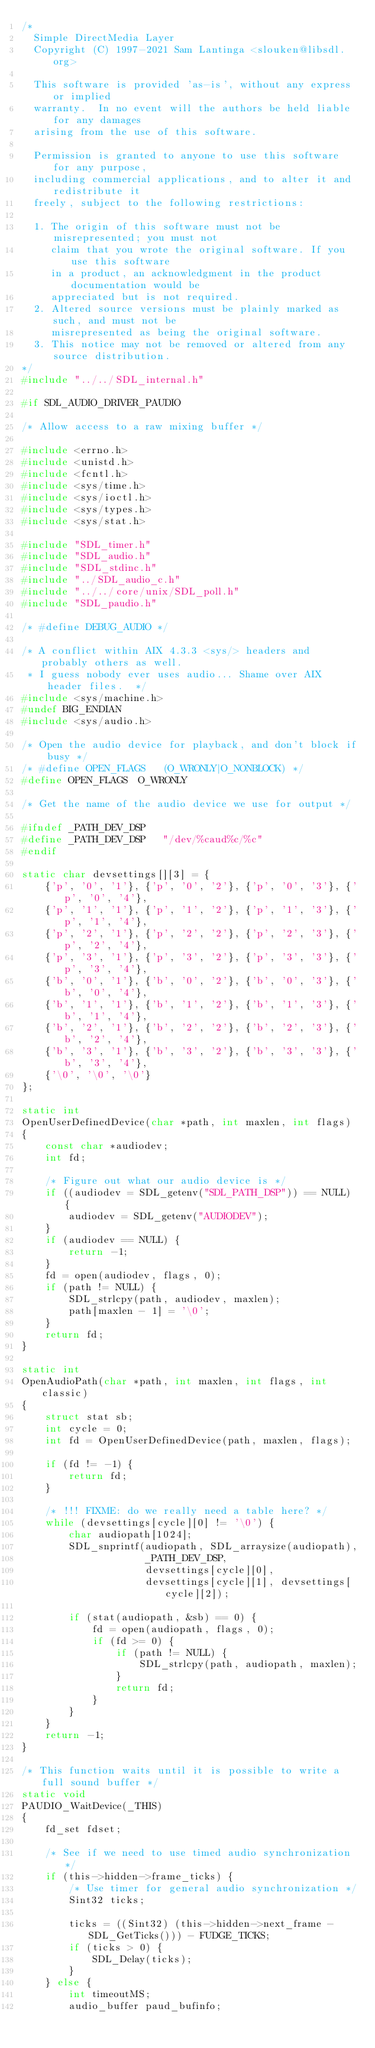<code> <loc_0><loc_0><loc_500><loc_500><_C_>/*
  Simple DirectMedia Layer
  Copyright (C) 1997-2021 Sam Lantinga <slouken@libsdl.org>

  This software is provided 'as-is', without any express or implied
  warranty.  In no event will the authors be held liable for any damages
  arising from the use of this software.

  Permission is granted to anyone to use this software for any purpose,
  including commercial applications, and to alter it and redistribute it
  freely, subject to the following restrictions:

  1. The origin of this software must not be misrepresented; you must not
     claim that you wrote the original software. If you use this software
     in a product, an acknowledgment in the product documentation would be
     appreciated but is not required.
  2. Altered source versions must be plainly marked as such, and must not be
     misrepresented as being the original software.
  3. This notice may not be removed or altered from any source distribution.
*/
#include "../../SDL_internal.h"

#if SDL_AUDIO_DRIVER_PAUDIO

/* Allow access to a raw mixing buffer */

#include <errno.h>
#include <unistd.h>
#include <fcntl.h>
#include <sys/time.h>
#include <sys/ioctl.h>
#include <sys/types.h>
#include <sys/stat.h>

#include "SDL_timer.h"
#include "SDL_audio.h"
#include "SDL_stdinc.h"
#include "../SDL_audio_c.h"
#include "../../core/unix/SDL_poll.h"
#include "SDL_paudio.h"

/* #define DEBUG_AUDIO */

/* A conflict within AIX 4.3.3 <sys/> headers and probably others as well.
 * I guess nobody ever uses audio... Shame over AIX header files.  */
#include <sys/machine.h>
#undef BIG_ENDIAN
#include <sys/audio.h>

/* Open the audio device for playback, and don't block if busy */
/* #define OPEN_FLAGS   (O_WRONLY|O_NONBLOCK) */
#define OPEN_FLAGS  O_WRONLY

/* Get the name of the audio device we use for output */

#ifndef _PATH_DEV_DSP
#define _PATH_DEV_DSP   "/dev/%caud%c/%c"
#endif

static char devsettings[][3] = {
    {'p', '0', '1'}, {'p', '0', '2'}, {'p', '0', '3'}, {'p', '0', '4'},
    {'p', '1', '1'}, {'p', '1', '2'}, {'p', '1', '3'}, {'p', '1', '4'},
    {'p', '2', '1'}, {'p', '2', '2'}, {'p', '2', '3'}, {'p', '2', '4'},
    {'p', '3', '1'}, {'p', '3', '2'}, {'p', '3', '3'}, {'p', '3', '4'},
    {'b', '0', '1'}, {'b', '0', '2'}, {'b', '0', '3'}, {'b', '0', '4'},
    {'b', '1', '1'}, {'b', '1', '2'}, {'b', '1', '3'}, {'b', '1', '4'},
    {'b', '2', '1'}, {'b', '2', '2'}, {'b', '2', '3'}, {'b', '2', '4'},
    {'b', '3', '1'}, {'b', '3', '2'}, {'b', '3', '3'}, {'b', '3', '4'},
    {'\0', '\0', '\0'}
};

static int
OpenUserDefinedDevice(char *path, int maxlen, int flags)
{
    const char *audiodev;
    int fd;

    /* Figure out what our audio device is */
    if ((audiodev = SDL_getenv("SDL_PATH_DSP")) == NULL) {
        audiodev = SDL_getenv("AUDIODEV");
    }
    if (audiodev == NULL) {
        return -1;
    }
    fd = open(audiodev, flags, 0);
    if (path != NULL) {
        SDL_strlcpy(path, audiodev, maxlen);
        path[maxlen - 1] = '\0';
    }
    return fd;
}

static int
OpenAudioPath(char *path, int maxlen, int flags, int classic)
{
    struct stat sb;
    int cycle = 0;
    int fd = OpenUserDefinedDevice(path, maxlen, flags);

    if (fd != -1) {
        return fd;
    }

    /* !!! FIXME: do we really need a table here? */
    while (devsettings[cycle][0] != '\0') {
        char audiopath[1024];
        SDL_snprintf(audiopath, SDL_arraysize(audiopath),
                     _PATH_DEV_DSP,
                     devsettings[cycle][0],
                     devsettings[cycle][1], devsettings[cycle][2]);

        if (stat(audiopath, &sb) == 0) {
            fd = open(audiopath, flags, 0);
            if (fd >= 0) {
                if (path != NULL) {
                    SDL_strlcpy(path, audiopath, maxlen);
                }
                return fd;
            }
        }
    }
    return -1;
}

/* This function waits until it is possible to write a full sound buffer */
static void
PAUDIO_WaitDevice(_THIS)
{
    fd_set fdset;

    /* See if we need to use timed audio synchronization */
    if (this->hidden->frame_ticks) {
        /* Use timer for general audio synchronization */
        Sint32 ticks;

        ticks = ((Sint32) (this->hidden->next_frame - SDL_GetTicks())) - FUDGE_TICKS;
        if (ticks > 0) {
            SDL_Delay(ticks);
        }
    } else {
        int timeoutMS;
        audio_buffer paud_bufinfo;
</code> 